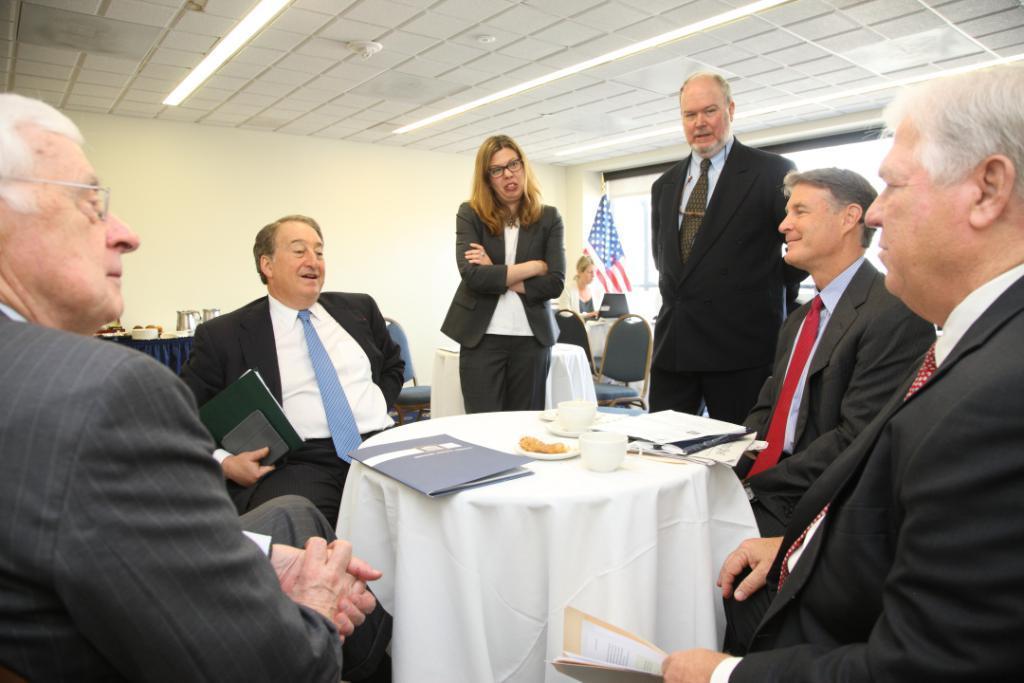Describe this image in one or two sentences. There are four persons sitting on the chairs. This is table. On the table there is a cloth, caps, papers, and food. Here we can see two persons are standing on the floor. These are the chairs. On the background there is a wall and this is flag. And there are lights and this is roof. 